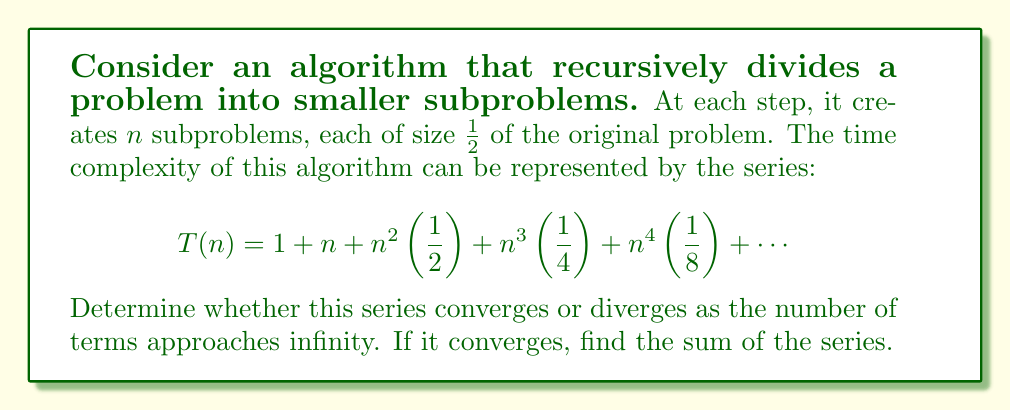Teach me how to tackle this problem. To analyze the convergence of this series, we can use the ratio test:

1) Let $a_k = n^k\left(\frac{1}{2^{k-1}}\right)$ be the general term of the series (excluding the first two terms).

2) We calculate the limit of the ratio of consecutive terms:

   $$\lim_{k\to\infty} \left|\frac{a_{k+1}}{a_k}\right| = \lim_{k\to\infty} \left|\frac{n^{k+1}\left(\frac{1}{2^k}\right)}{n^k\left(\frac{1}{2^{k-1}}\right)}\right| = \lim_{k\to\infty} \left|\frac{n}{2}\right| = \frac{n}{2}$$

3) If this limit is less than 1, the series converges. If it's greater than 1, the series diverges.

4) The series converges if $\frac{n}{2} < 1$, or $n < 2$.

5) For $n < 2$, we can find the sum of the series:

   Let $S = 1 + n + n^2\left(\frac{1}{2}\right) + n^3\left(\frac{1}{4}\right) + n^4\left(\frac{1}{8}\right) + ...$

   Multiply both sides by $\frac{n}{2}$:

   $\frac{n}{2}S = \frac{n}{2} + \frac{n^2}{2} + n^3\left(\frac{1}{4}\right) + n^4\left(\frac{1}{8}\right) + ...$

   Subtract this from the original equation:

   $S - \frac{n}{2}S = 1 + n + \frac{n^2}{2}$

   $S\left(1 - \frac{n}{2}\right) = 1 + n + \frac{n^2}{2}$

   $S = \frac{1 + n + \frac{n^2}{2}}{1 - \frac{n}{2}} = \frac{2 + 2n + n^2}{2 - n}$

For $n \geq 2$, the series diverges.
Answer: The series converges for $n < 2$ with sum $\frac{2 + 2n + n^2}{2 - n}$, and diverges for $n \geq 2$. 